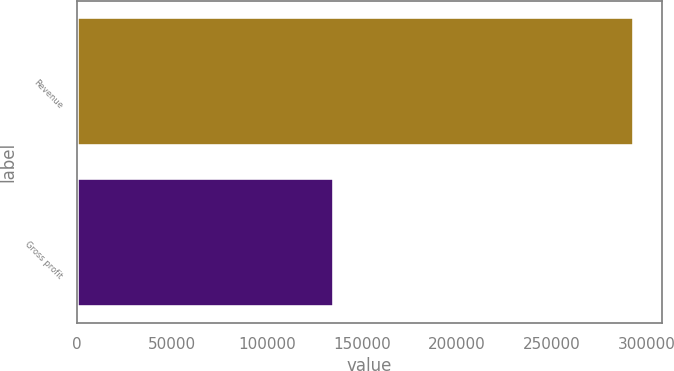Convert chart. <chart><loc_0><loc_0><loc_500><loc_500><bar_chart><fcel>Revenue<fcel>Gross profit<nl><fcel>293461<fcel>135195<nl></chart> 